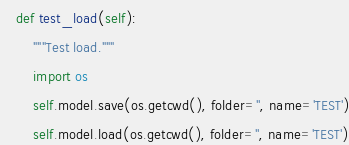<code> <loc_0><loc_0><loc_500><loc_500><_Python_>    def test_load(self):
        """Test load."""
        import os
        self.model.save(os.getcwd(), folder='', name='TEST')
        self.model.load(os.getcwd(), folder='', name='TEST')
</code> 